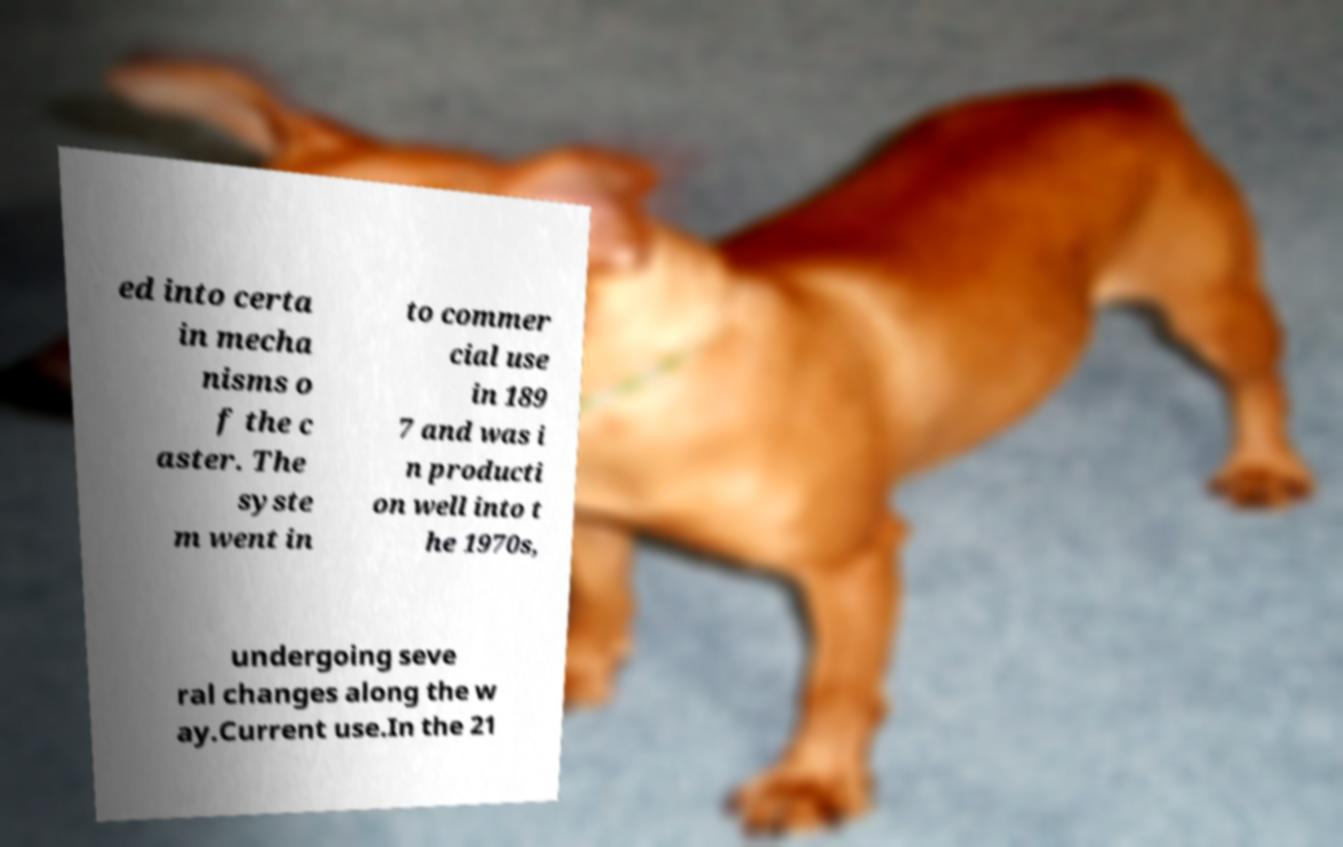There's text embedded in this image that I need extracted. Can you transcribe it verbatim? ed into certa in mecha nisms o f the c aster. The syste m went in to commer cial use in 189 7 and was i n producti on well into t he 1970s, undergoing seve ral changes along the w ay.Current use.In the 21 